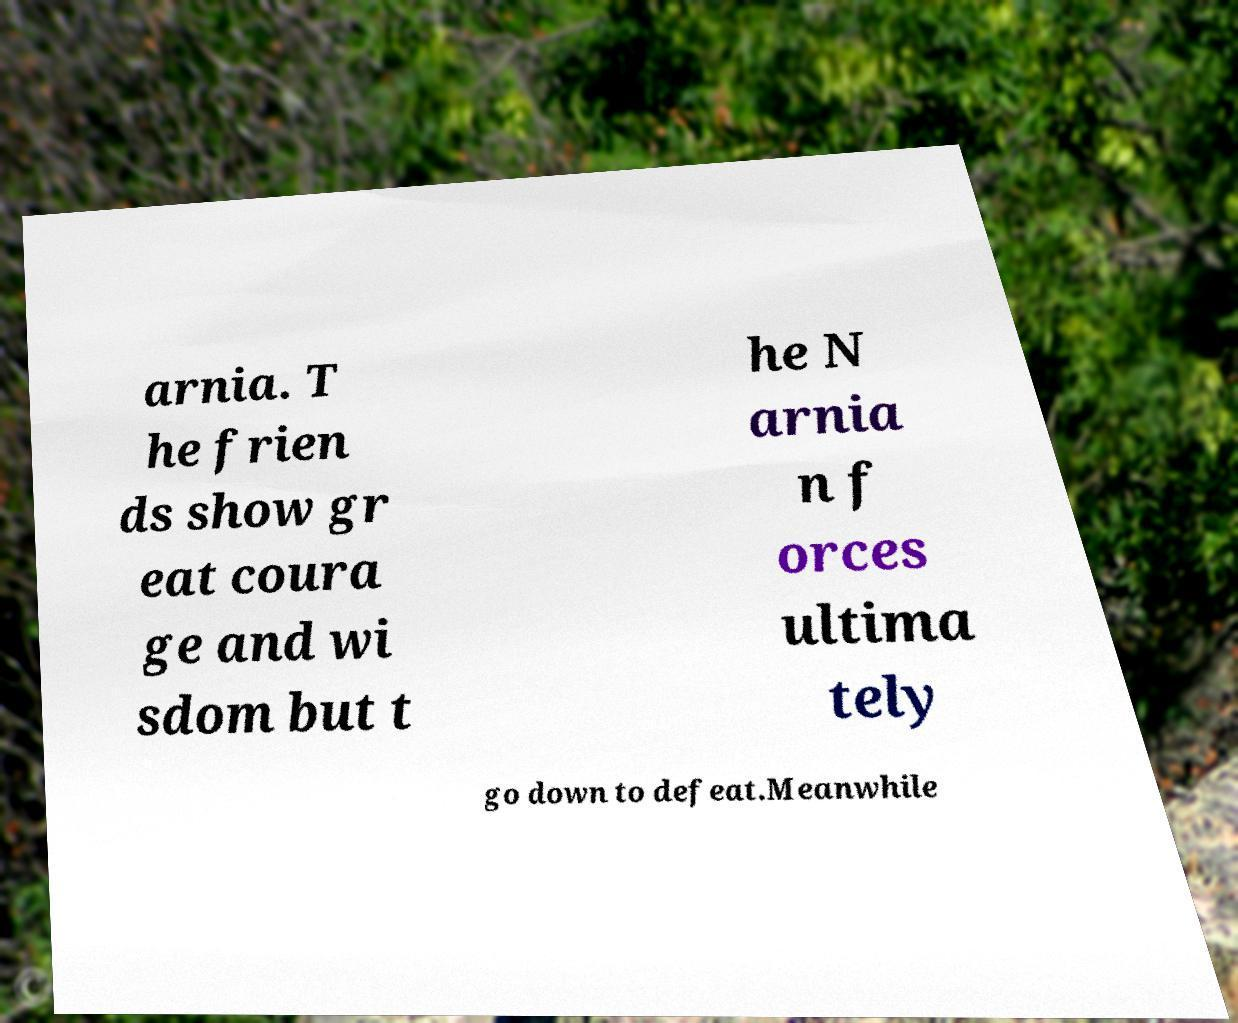Please read and relay the text visible in this image. What does it say? arnia. T he frien ds show gr eat coura ge and wi sdom but t he N arnia n f orces ultima tely go down to defeat.Meanwhile 